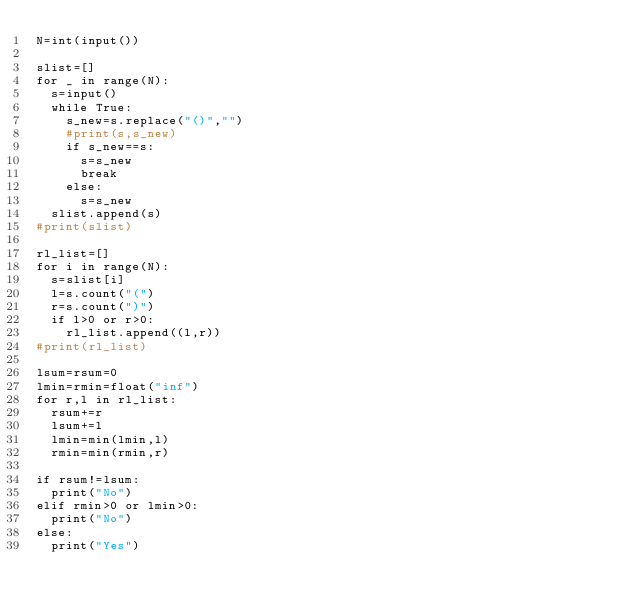Convert code to text. <code><loc_0><loc_0><loc_500><loc_500><_Python_>N=int(input())

slist=[]
for _ in range(N):
  s=input()
  while True:
    s_new=s.replace("()","")
    #print(s,s_new)
    if s_new==s:
      s=s_new
      break
    else:
      s=s_new
  slist.append(s)
#print(slist)

rl_list=[]
for i in range(N):
  s=slist[i]
  l=s.count("(")
  r=s.count(")")
  if l>0 or r>0:
    rl_list.append((l,r))
#print(rl_list)
  
lsum=rsum=0
lmin=rmin=float("inf")
for r,l in rl_list:
  rsum+=r
  lsum+=l
  lmin=min(lmin,l)
  rmin=min(rmin,r)
  
if rsum!=lsum:
  print("No")
elif rmin>0 or lmin>0:
  print("No")
else:
  print("Yes")</code> 